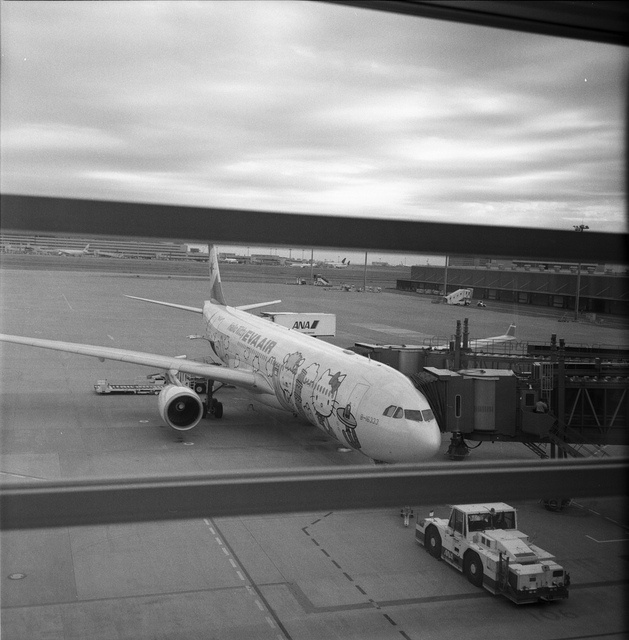Describe the objects in this image and their specific colors. I can see airplane in darkgray, gray, lightgray, and black tones, truck in darkgray, black, gray, and lightgray tones, airplane in darkgray, gray, and silver tones, people in black and darkgray tones, and airplane in darkgray, gray, lightgray, and black tones in this image. 